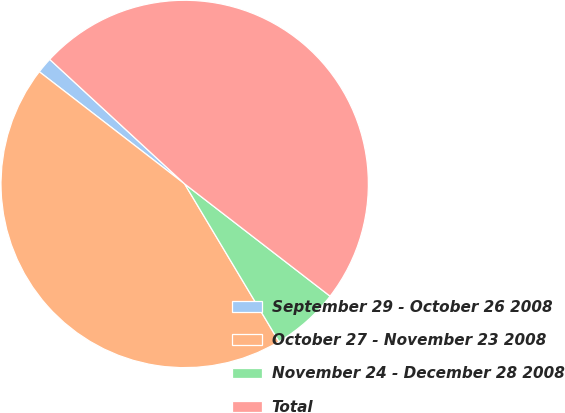Convert chart to OTSL. <chart><loc_0><loc_0><loc_500><loc_500><pie_chart><fcel>September 29 - October 26 2008<fcel>October 27 - November 23 2008<fcel>November 24 - December 28 2008<fcel>Total<nl><fcel>1.4%<fcel>44.04%<fcel>5.96%<fcel>48.6%<nl></chart> 